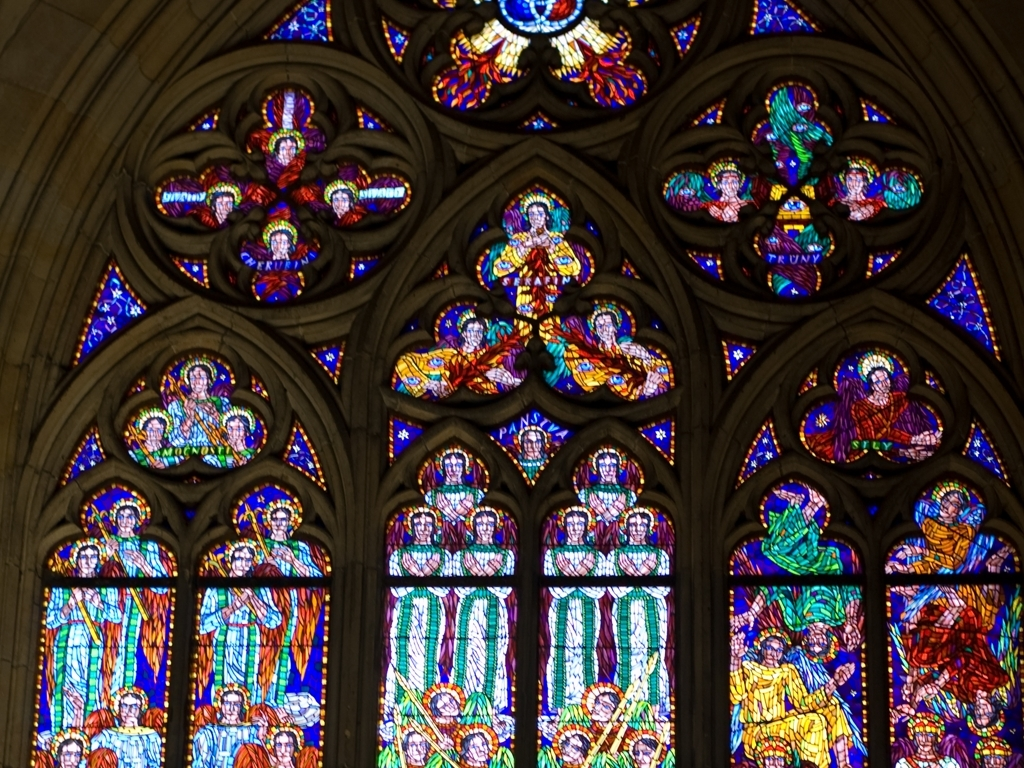Can you describe the style or historical period of the artwork shown in the image? The artwork shown in the image is a stained glass window, which is characteristic of Gothic architecture, likely dating back to the High or Late Middle Ages. The intricate design and vivid colors are typical of the period's emphasis on height, light, and grandeur within ecclesiastical settings. What might be the significance of the characters depicted in the stained glass? Stained glass windows often portray biblical scenes, saints, and other religious figures, serving both a didactic purpose and a spiritual one. The characters in this window may represent particular saints or apostles, meant to inspire and educate the congregants about their lives and virtues. 